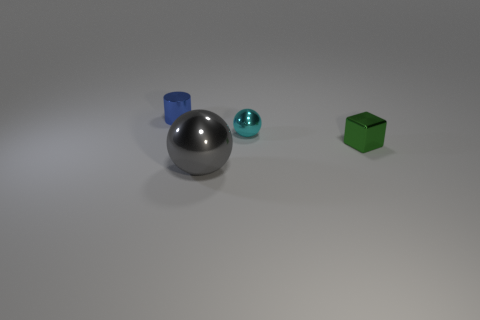Are there more small metallic objects that are on the left side of the gray shiny sphere than big yellow rubber spheres?
Make the answer very short. Yes. The blue cylinder that is the same material as the green object is what size?
Your answer should be compact. Small. How many objects are either red things or metal objects to the left of the cyan shiny sphere?
Give a very brief answer. 2. Is the number of metallic cylinders greater than the number of shiny balls?
Offer a terse response. No. Is there a small gray cylinder that has the same material as the small sphere?
Offer a very short reply. No. The metal object that is both in front of the small metal ball and on the left side of the green metallic cube has what shape?
Your answer should be compact. Sphere. What number of other objects are there of the same shape as the cyan metal object?
Offer a terse response. 1. How big is the blue thing?
Your response must be concise. Small. What number of objects are tiny cyan balls or large red things?
Offer a terse response. 1. There is a thing that is in front of the green thing; how big is it?
Your response must be concise. Large. 